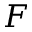Convert formula to latex. <formula><loc_0><loc_0><loc_500><loc_500>F</formula> 